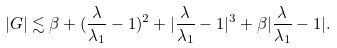<formula> <loc_0><loc_0><loc_500><loc_500>| G | \lesssim \beta + ( \frac { \lambda } { \lambda _ { 1 } } - 1 ) ^ { 2 } + | \frac { \lambda } { \lambda _ { 1 } } - 1 | ^ { 3 } + \beta | \frac { \lambda } { \lambda _ { 1 } } - 1 | .</formula> 